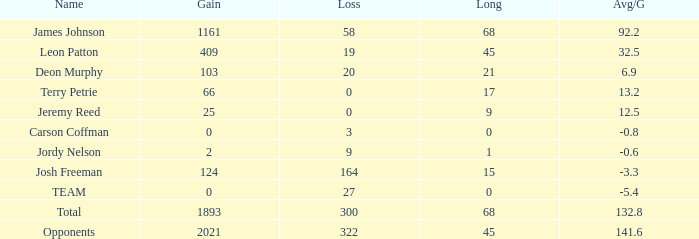How many losses did leon patton have with the longest gain higher than 45? 0.0. 